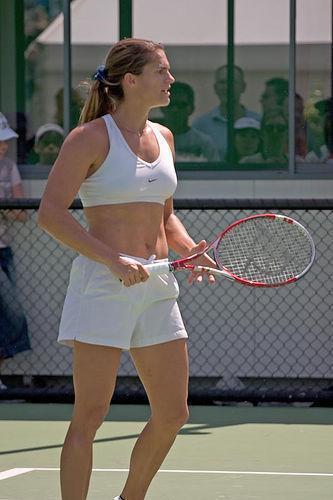How many tennis balls are there?
Give a very brief answer. 0. 